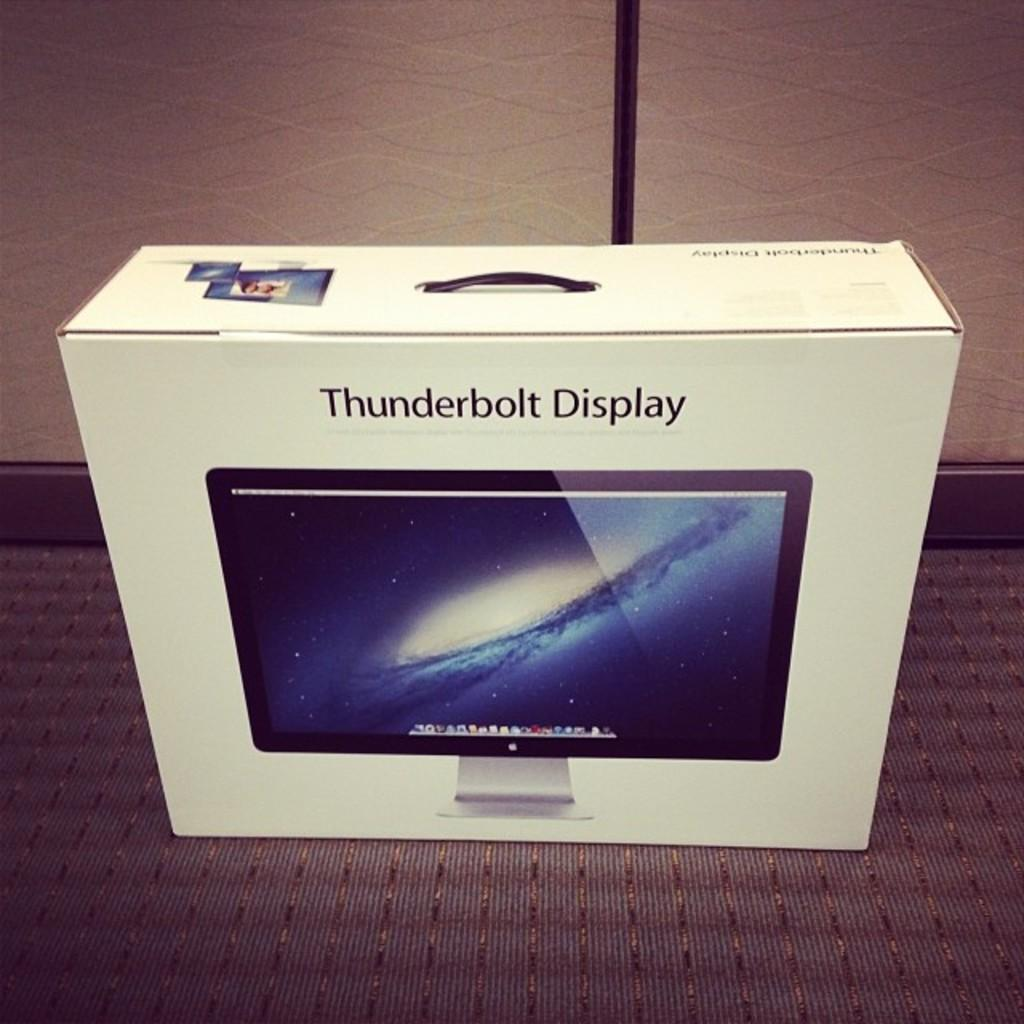<image>
Summarize the visual content of the image. A container for an Apple Thunderbolt Display computer. 